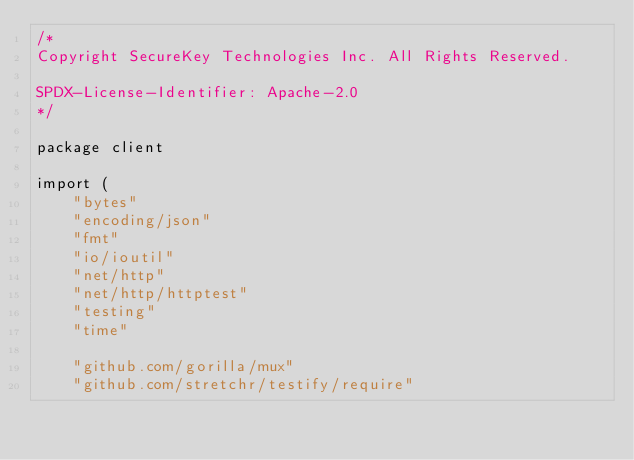<code> <loc_0><loc_0><loc_500><loc_500><_Go_>/*
Copyright SecureKey Technologies Inc. All Rights Reserved.

SPDX-License-Identifier: Apache-2.0
*/

package client

import (
	"bytes"
	"encoding/json"
	"fmt"
	"io/ioutil"
	"net/http"
	"net/http/httptest"
	"testing"
	"time"

	"github.com/gorilla/mux"
	"github.com/stretchr/testify/require"
</code> 